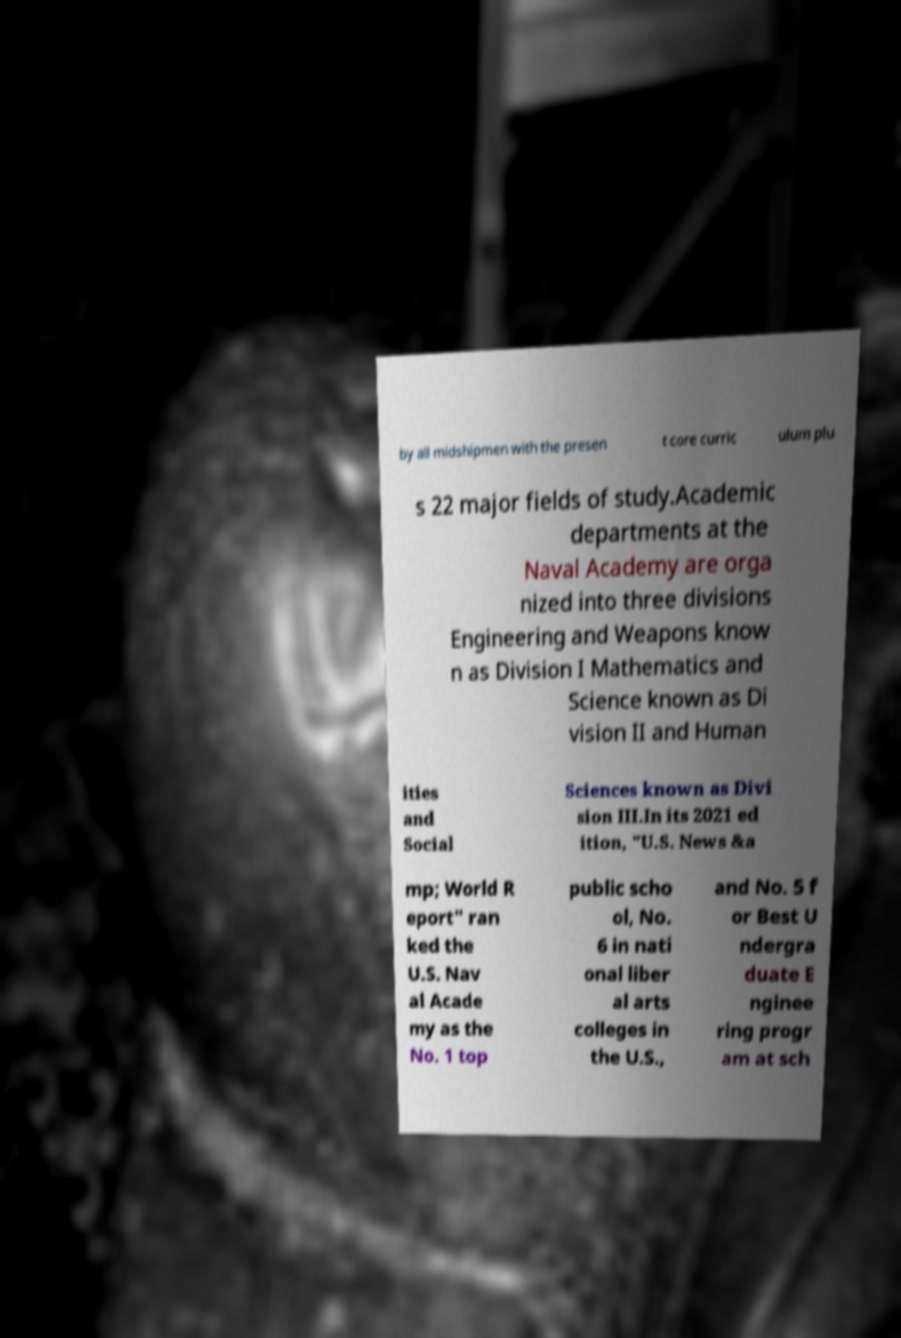Can you accurately transcribe the text from the provided image for me? by all midshipmen with the presen t core curric ulum plu s 22 major fields of study.Academic departments at the Naval Academy are orga nized into three divisions Engineering and Weapons know n as Division I Mathematics and Science known as Di vision II and Human ities and Social Sciences known as Divi sion III.In its 2021 ed ition, "U.S. News &a mp; World R eport" ran ked the U.S. Nav al Acade my as the No. 1 top public scho ol, No. 6 in nati onal liber al arts colleges in the U.S., and No. 5 f or Best U ndergra duate E nginee ring progr am at sch 